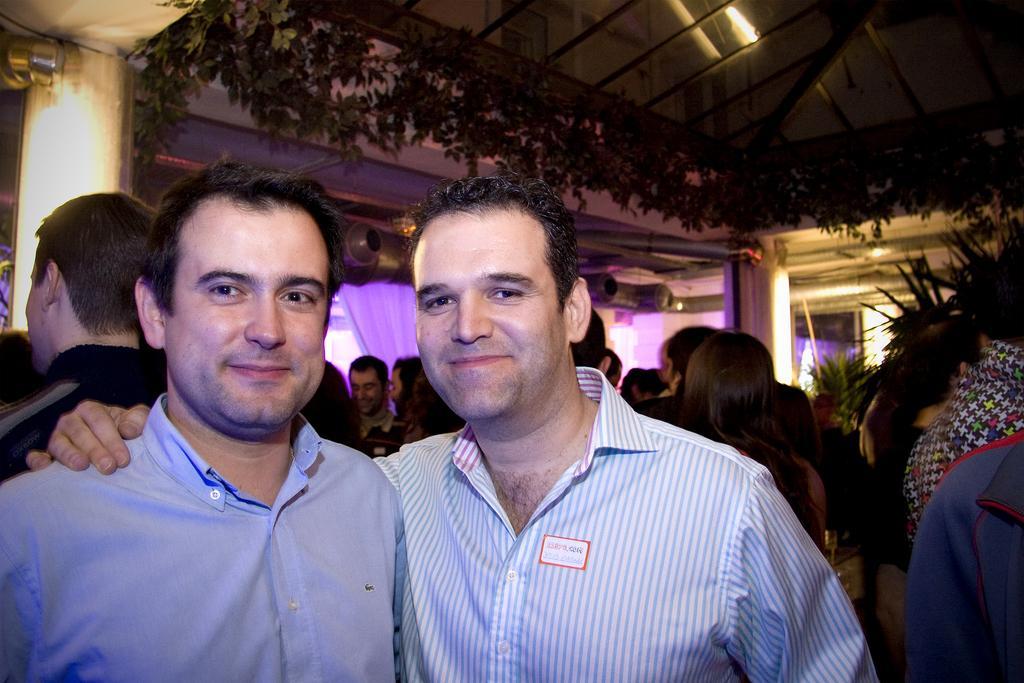Describe this image in one or two sentences. In this image we can see two men. In the background there are few persons, lights, pillars, curtains, plants, glass roof, poles and other objects. 